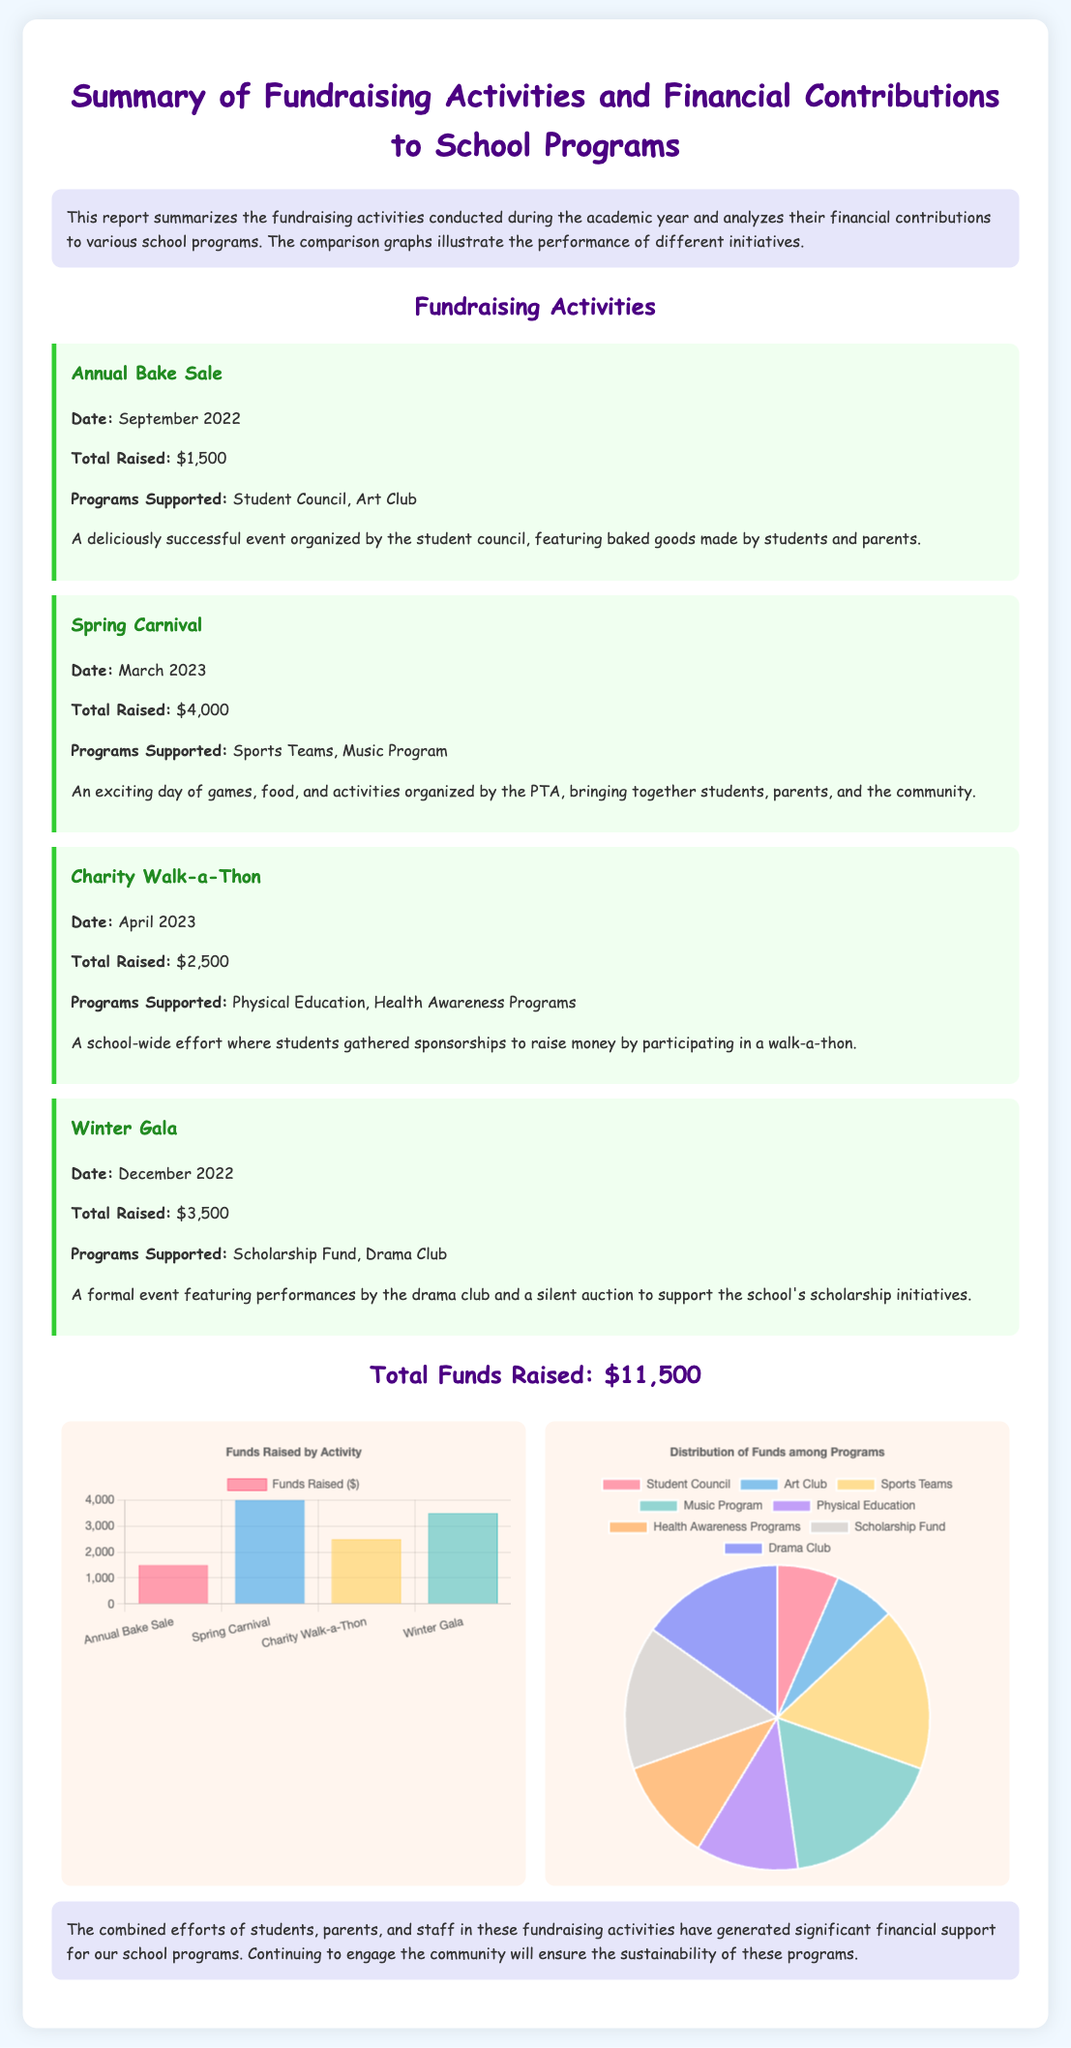What is the total amount raised from fundraising activities? The total amount raised from all the fundraising activities listed is provided at the bottom of the document.
Answer: $11,500 When was the Spring Carnival held? The date of the Spring Carnival is specified in the description of the event.
Answer: March 2023 What programs did the Annual Bake Sale support? The document mentions the programs supported by the Annual Bake Sale in its description.
Answer: Student Council, Art Club Which fundraising activity raised the most money? The amounts raised by each activity can be compared to determine which one was the most successful.
Answer: Spring Carnival How much money was raised from the Charity Walk-a-Thon? The specific amount raised by the Charity Walk-a-Thon is presented in the event description.
Answer: $2,500 What type of graph is used to show the distribution of funds among programs? The document describes the type of graphs used to present the fundraising data.
Answer: Pie Chart What is the title of the document? The title is prominently displayed at the top of the report, summarizing its content.
Answer: Summary of Fundraising Activities and Financial Contributions to School Programs How many fundraising activities are documented here? The number of activities can be counted from the sections of the document outlining each event.
Answer: 4 